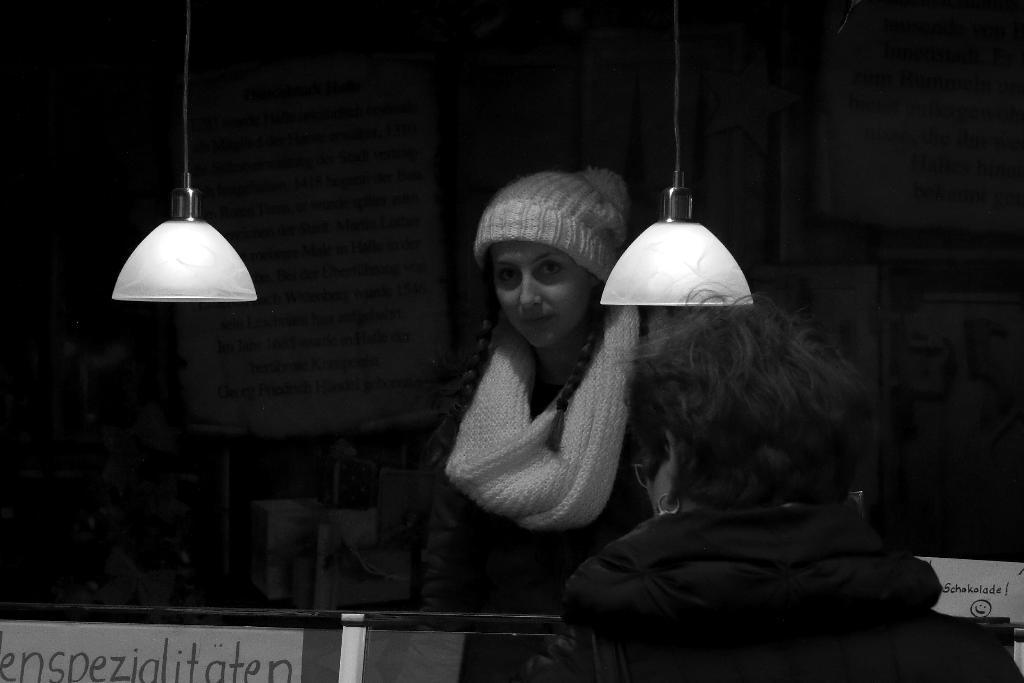How would you summarize this image in a sentence or two? In this picture we can see two persons, there are two lights here, in the background there is a board, we can see handwritten text on the board, it is a black and white picture. 